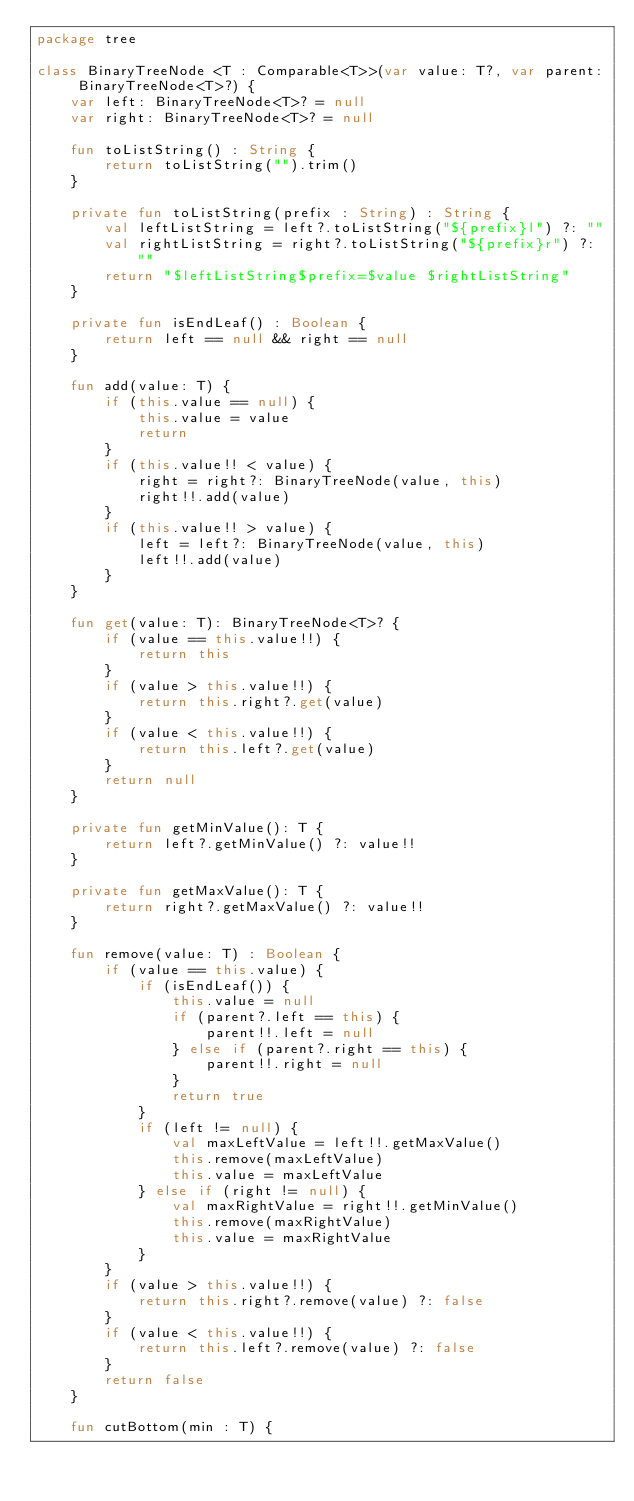<code> <loc_0><loc_0><loc_500><loc_500><_Kotlin_>package tree

class BinaryTreeNode <T : Comparable<T>>(var value: T?, var parent: BinaryTreeNode<T>?) {
    var left: BinaryTreeNode<T>? = null
    var right: BinaryTreeNode<T>? = null

    fun toListString() : String {
        return toListString("").trim()
    }

    private fun toListString(prefix : String) : String {
        val leftListString = left?.toListString("${prefix}l") ?: ""
        val rightListString = right?.toListString("${prefix}r") ?: ""
        return "$leftListString$prefix=$value $rightListString"
    }

    private fun isEndLeaf() : Boolean {
        return left == null && right == null
    }

    fun add(value: T) {
        if (this.value == null) {
            this.value = value
            return
        }
        if (this.value!! < value) {
            right = right?: BinaryTreeNode(value, this)
            right!!.add(value)
        }
        if (this.value!! > value) {
            left = left?: BinaryTreeNode(value, this)
            left!!.add(value)
        }
    }

    fun get(value: T): BinaryTreeNode<T>? {
        if (value == this.value!!) {
            return this
        }
        if (value > this.value!!) {
            return this.right?.get(value)
        }
        if (value < this.value!!) {
            return this.left?.get(value)
        }
        return null
    }

    private fun getMinValue(): T {
        return left?.getMinValue() ?: value!!
    }

    private fun getMaxValue(): T {
        return right?.getMaxValue() ?: value!!
    }

    fun remove(value: T) : Boolean {
        if (value == this.value) {
            if (isEndLeaf()) {
                this.value = null
                if (parent?.left == this) {
                    parent!!.left = null
                } else if (parent?.right == this) {
                    parent!!.right = null
                }
                return true
            }
            if (left != null) {
                val maxLeftValue = left!!.getMaxValue()
                this.remove(maxLeftValue)
                this.value = maxLeftValue
            } else if (right != null) {
                val maxRightValue = right!!.getMinValue()
                this.remove(maxRightValue)
                this.value = maxRightValue
            }
        }
        if (value > this.value!!) {
            return this.right?.remove(value) ?: false
        }
        if (value < this.value!!) {
            return this.left?.remove(value) ?: false
        }
        return false
    }

    fun cutBottom(min : T) {</code> 